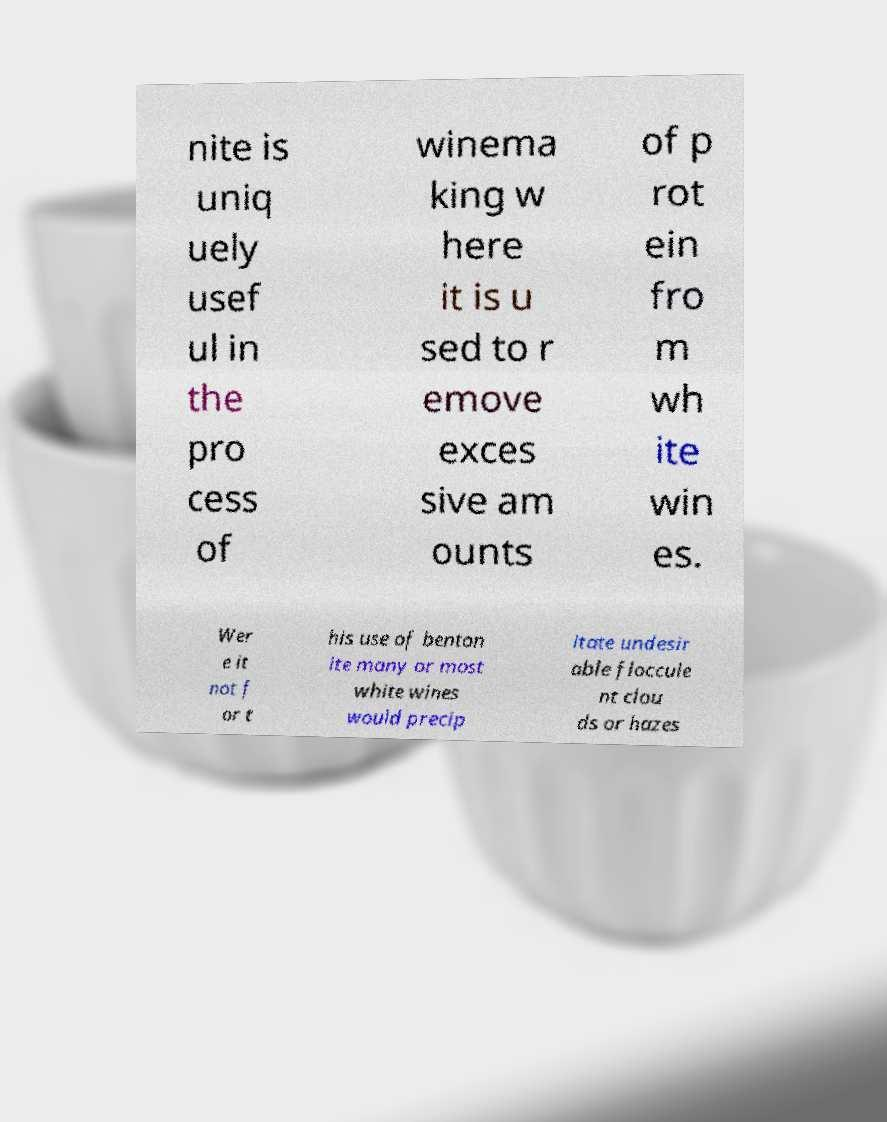I need the written content from this picture converted into text. Can you do that? nite is uniq uely usef ul in the pro cess of winema king w here it is u sed to r emove exces sive am ounts of p rot ein fro m wh ite win es. Wer e it not f or t his use of benton ite many or most white wines would precip itate undesir able floccule nt clou ds or hazes 